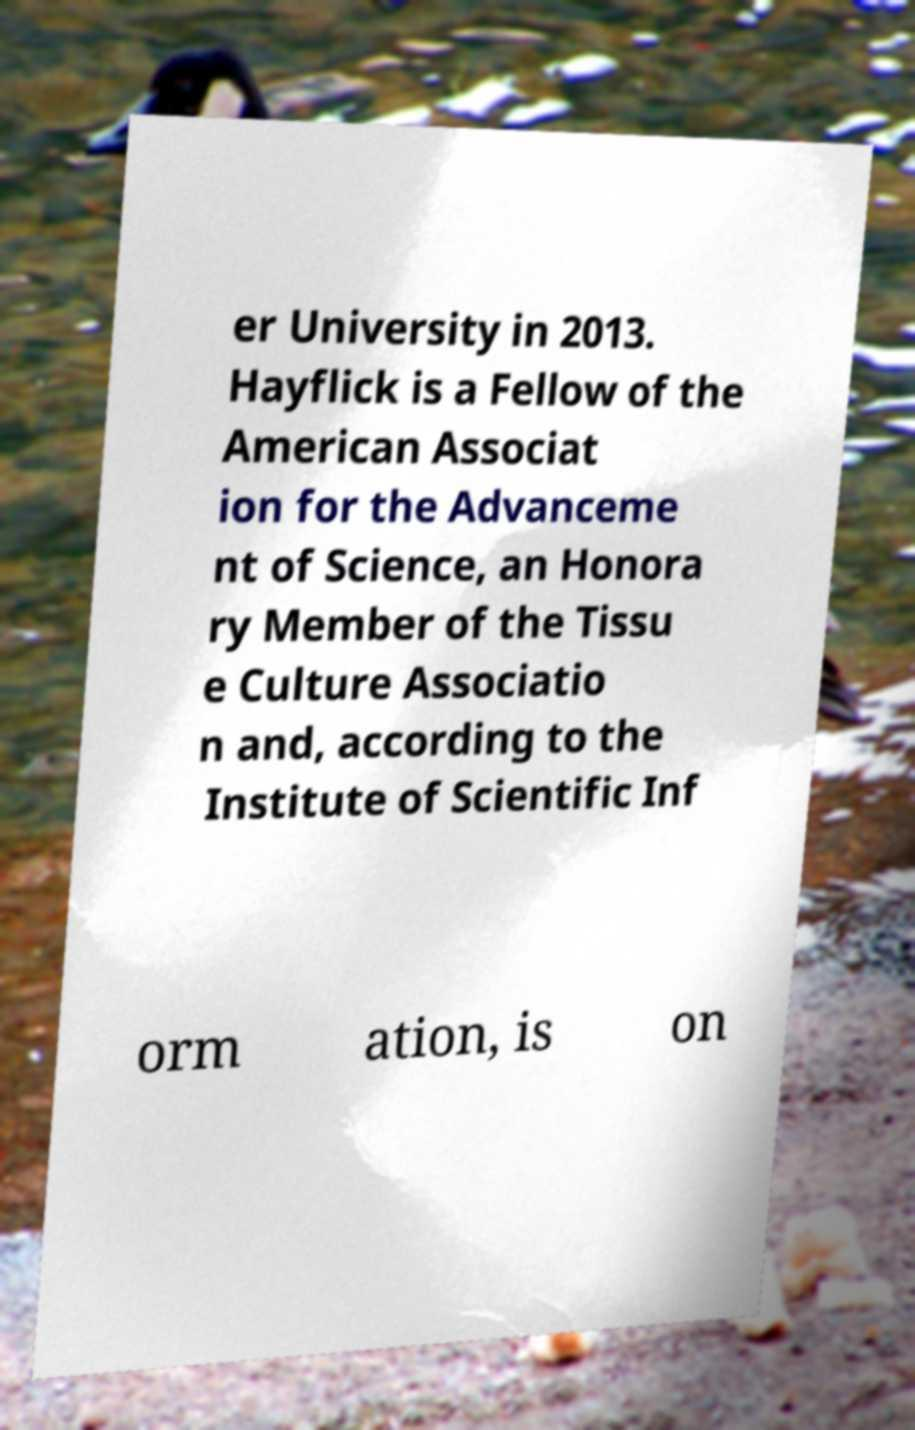There's text embedded in this image that I need extracted. Can you transcribe it verbatim? er University in 2013. Hayflick is a Fellow of the American Associat ion for the Advanceme nt of Science, an Honora ry Member of the Tissu e Culture Associatio n and, according to the Institute of Scientific Inf orm ation, is on 